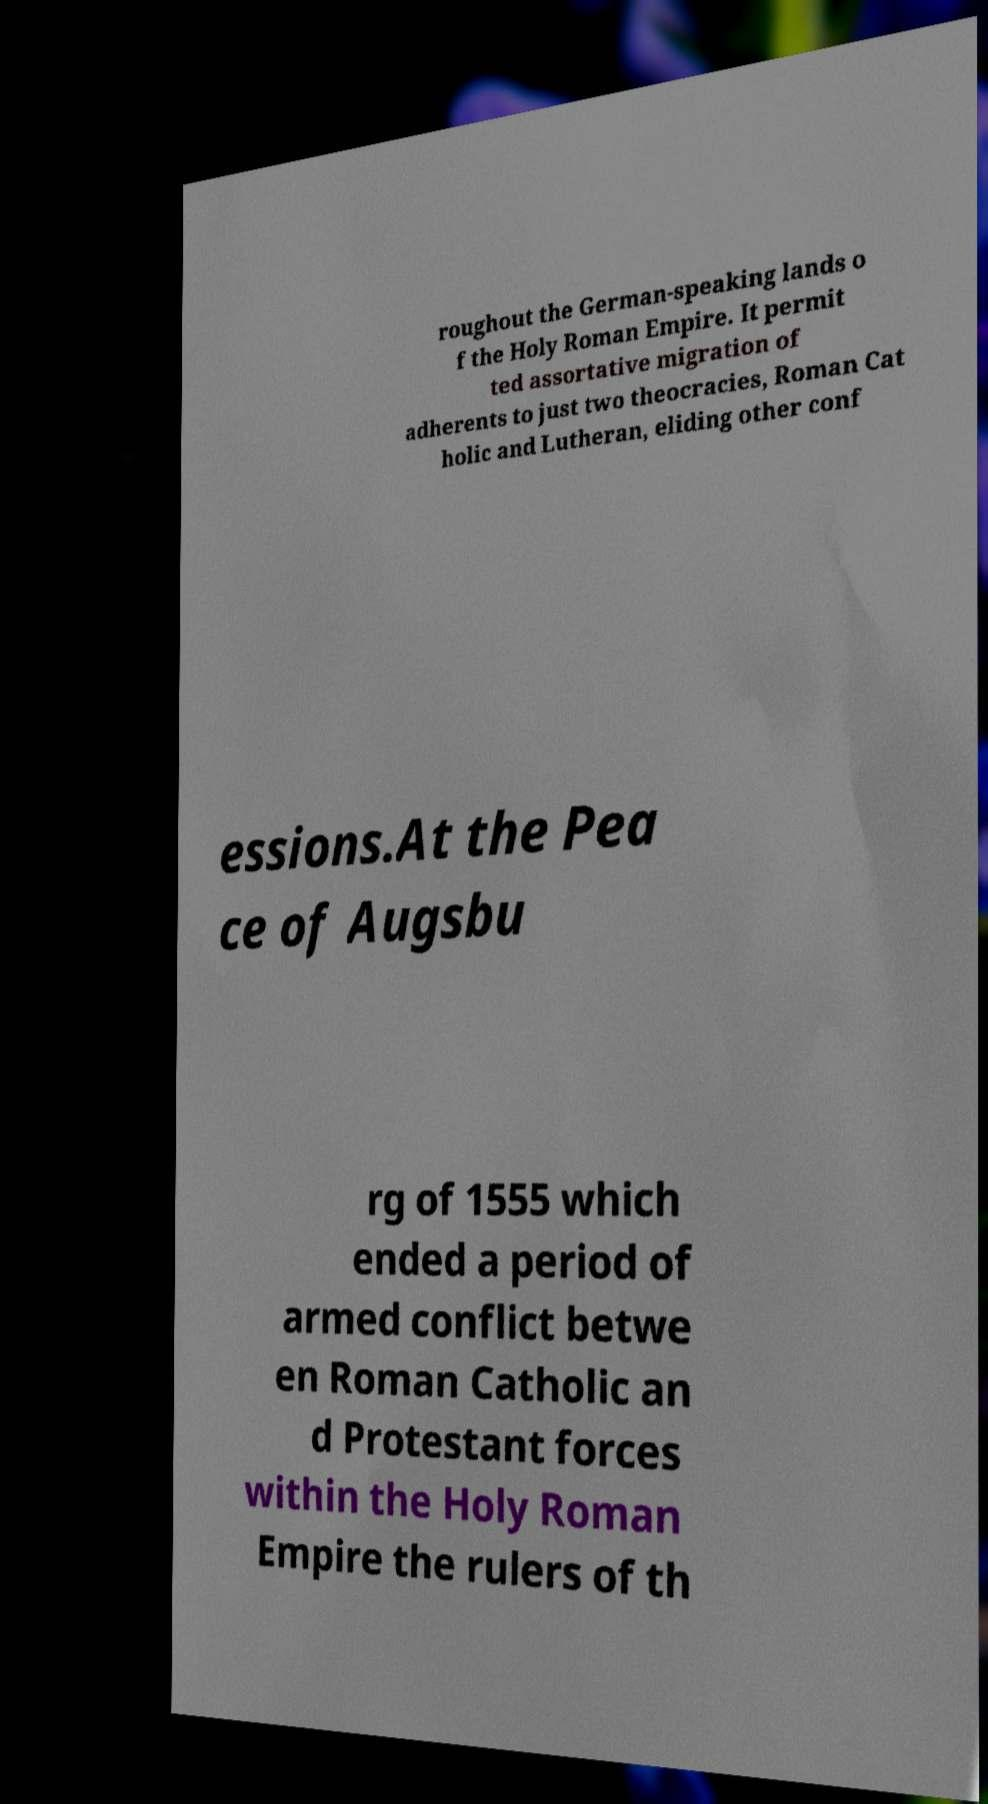Can you accurately transcribe the text from the provided image for me? roughout the German-speaking lands o f the Holy Roman Empire. It permit ted assortative migration of adherents to just two theocracies, Roman Cat holic and Lutheran, eliding other conf essions.At the Pea ce of Augsbu rg of 1555 which ended a period of armed conflict betwe en Roman Catholic an d Protestant forces within the Holy Roman Empire the rulers of th 